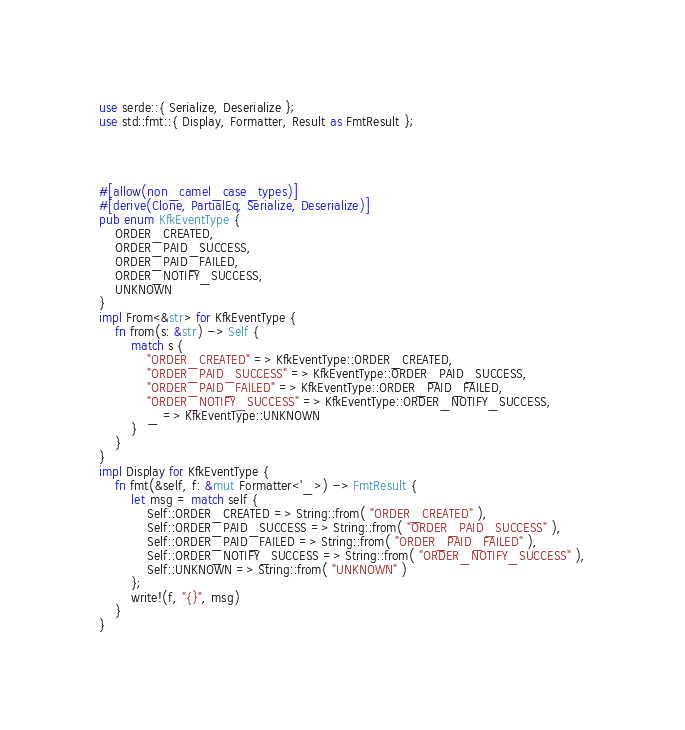Convert code to text. <code><loc_0><loc_0><loc_500><loc_500><_Rust_>use serde::{ Serialize, Deserialize };
use std::fmt::{ Display, Formatter, Result as FmtResult };




#[allow(non_camel_case_types)]
#[derive(Clone, PartialEq, Serialize, Deserialize)]
pub enum KfkEventType {
    ORDER_CREATED,
    ORDER_PAID_SUCCESS,
    ORDER_PAID_FAILED,
    ORDER_NOTIFY_SUCCESS,
    UNKNOWN
}
impl From<&str> for KfkEventType {
    fn from(s: &str) -> Self {
        match s {
            "ORDER_CREATED" => KfkEventType::ORDER_CREATED,
            "ORDER_PAID_SUCCESS" => KfkEventType::ORDER_PAID_SUCCESS,
            "ORDER_PAID_FAILED" => KfkEventType::ORDER_PAID_FAILED,
            "ORDER_NOTIFY_SUCCESS" => KfkEventType::ORDER_NOTIFY_SUCCESS,
            _ => KfkEventType::UNKNOWN
        }
    }
}
impl Display for KfkEventType {
    fn fmt(&self, f: &mut Formatter<'_>) -> FmtResult {
        let msg = match self {
            Self::ORDER_CREATED => String::from( "ORDER_CREATED" ),
            Self::ORDER_PAID_SUCCESS => String::from( "ORDER_PAID_SUCCESS" ),
            Self::ORDER_PAID_FAILED => String::from( "ORDER_PAID_FAILED" ),
            Self::ORDER_NOTIFY_SUCCESS => String::from( "ORDER_NOTIFY_SUCCESS" ),
            Self::UNKNOWN => String::from( "UNKNOWN" )
        };
        write!(f, "{}", msg)
    }
}
</code> 